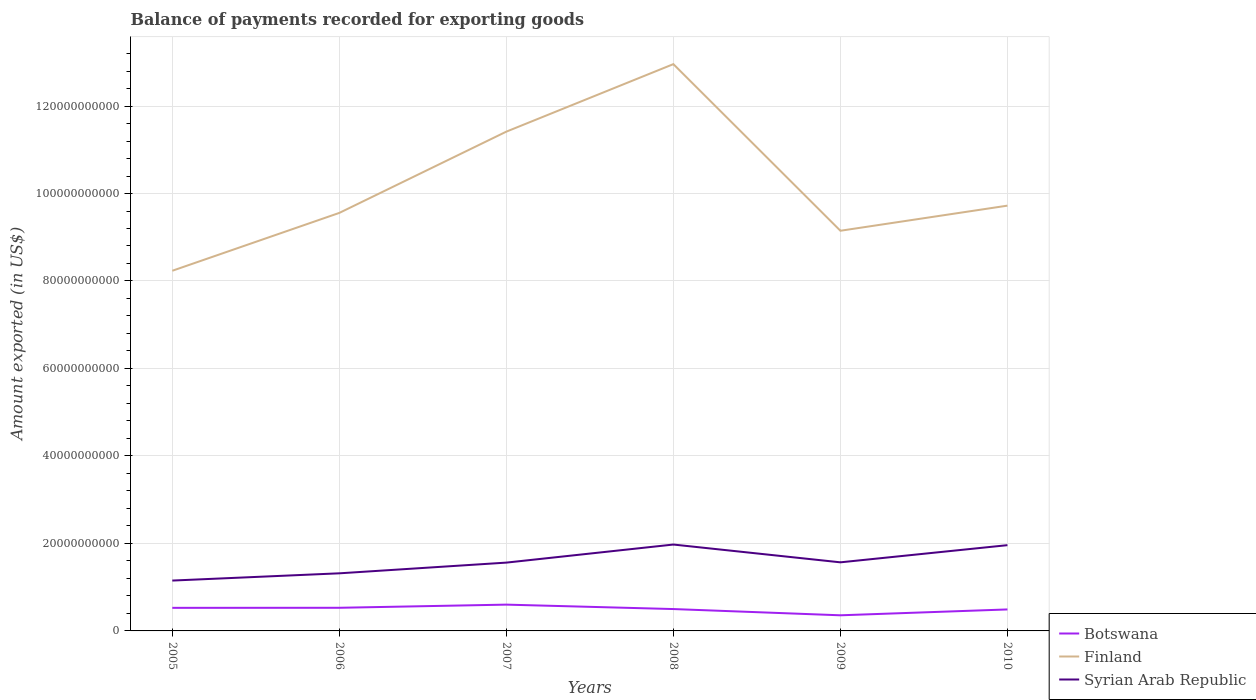Does the line corresponding to Syrian Arab Republic intersect with the line corresponding to Botswana?
Give a very brief answer. No. Across all years, what is the maximum amount exported in Botswana?
Offer a terse response. 3.57e+09. What is the total amount exported in Finland in the graph?
Offer a very short reply. -1.66e+09. What is the difference between the highest and the second highest amount exported in Finland?
Your response must be concise. 4.72e+1. What is the difference between the highest and the lowest amount exported in Syrian Arab Republic?
Ensure brevity in your answer.  2. How many years are there in the graph?
Your answer should be compact. 6. Does the graph contain any zero values?
Keep it short and to the point. No. Where does the legend appear in the graph?
Offer a terse response. Bottom right. How many legend labels are there?
Ensure brevity in your answer.  3. What is the title of the graph?
Your response must be concise. Balance of payments recorded for exporting goods. Does "Maldives" appear as one of the legend labels in the graph?
Provide a short and direct response. No. What is the label or title of the Y-axis?
Provide a succinct answer. Amount exported (in US$). What is the Amount exported (in US$) in Botswana in 2005?
Offer a very short reply. 5.28e+09. What is the Amount exported (in US$) of Finland in 2005?
Your response must be concise. 8.23e+1. What is the Amount exported (in US$) in Syrian Arab Republic in 2005?
Provide a succinct answer. 1.15e+1. What is the Amount exported (in US$) of Botswana in 2006?
Your answer should be very brief. 5.29e+09. What is the Amount exported (in US$) of Finland in 2006?
Offer a very short reply. 9.56e+1. What is the Amount exported (in US$) of Syrian Arab Republic in 2006?
Provide a short and direct response. 1.32e+1. What is the Amount exported (in US$) of Botswana in 2007?
Your answer should be compact. 6.01e+09. What is the Amount exported (in US$) in Finland in 2007?
Make the answer very short. 1.14e+11. What is the Amount exported (in US$) of Syrian Arab Republic in 2007?
Your answer should be compact. 1.56e+1. What is the Amount exported (in US$) in Botswana in 2008?
Ensure brevity in your answer.  5.00e+09. What is the Amount exported (in US$) in Finland in 2008?
Offer a very short reply. 1.30e+11. What is the Amount exported (in US$) of Syrian Arab Republic in 2008?
Keep it short and to the point. 1.97e+1. What is the Amount exported (in US$) in Botswana in 2009?
Provide a succinct answer. 3.57e+09. What is the Amount exported (in US$) in Finland in 2009?
Ensure brevity in your answer.  9.15e+1. What is the Amount exported (in US$) in Syrian Arab Republic in 2009?
Make the answer very short. 1.57e+1. What is the Amount exported (in US$) of Botswana in 2010?
Your response must be concise. 4.91e+09. What is the Amount exported (in US$) in Finland in 2010?
Keep it short and to the point. 9.72e+1. What is the Amount exported (in US$) of Syrian Arab Republic in 2010?
Provide a succinct answer. 1.96e+1. Across all years, what is the maximum Amount exported (in US$) in Botswana?
Provide a short and direct response. 6.01e+09. Across all years, what is the maximum Amount exported (in US$) in Finland?
Your response must be concise. 1.30e+11. Across all years, what is the maximum Amount exported (in US$) of Syrian Arab Republic?
Ensure brevity in your answer.  1.97e+1. Across all years, what is the minimum Amount exported (in US$) in Botswana?
Your answer should be compact. 3.57e+09. Across all years, what is the minimum Amount exported (in US$) in Finland?
Keep it short and to the point. 8.23e+1. Across all years, what is the minimum Amount exported (in US$) of Syrian Arab Republic?
Your answer should be very brief. 1.15e+1. What is the total Amount exported (in US$) of Botswana in the graph?
Your answer should be very brief. 3.01e+1. What is the total Amount exported (in US$) of Finland in the graph?
Your answer should be compact. 6.10e+11. What is the total Amount exported (in US$) of Syrian Arab Republic in the graph?
Your answer should be compact. 9.53e+1. What is the difference between the Amount exported (in US$) in Botswana in 2005 and that in 2006?
Provide a short and direct response. -1.42e+07. What is the difference between the Amount exported (in US$) in Finland in 2005 and that in 2006?
Give a very brief answer. -1.32e+1. What is the difference between the Amount exported (in US$) of Syrian Arab Republic in 2005 and that in 2006?
Keep it short and to the point. -1.66e+09. What is the difference between the Amount exported (in US$) of Botswana in 2005 and that in 2007?
Ensure brevity in your answer.  -7.35e+08. What is the difference between the Amount exported (in US$) of Finland in 2005 and that in 2007?
Provide a short and direct response. -3.18e+1. What is the difference between the Amount exported (in US$) of Syrian Arab Republic in 2005 and that in 2007?
Provide a short and direct response. -4.11e+09. What is the difference between the Amount exported (in US$) in Botswana in 2005 and that in 2008?
Provide a short and direct response. 2.78e+08. What is the difference between the Amount exported (in US$) in Finland in 2005 and that in 2008?
Offer a terse response. -4.72e+1. What is the difference between the Amount exported (in US$) of Syrian Arab Republic in 2005 and that in 2008?
Provide a short and direct response. -8.24e+09. What is the difference between the Amount exported (in US$) in Botswana in 2005 and that in 2009?
Ensure brevity in your answer.  1.70e+09. What is the difference between the Amount exported (in US$) in Finland in 2005 and that in 2009?
Give a very brief answer. -9.15e+09. What is the difference between the Amount exported (in US$) of Syrian Arab Republic in 2005 and that in 2009?
Your response must be concise. -4.17e+09. What is the difference between the Amount exported (in US$) of Botswana in 2005 and that in 2010?
Ensure brevity in your answer.  3.64e+08. What is the difference between the Amount exported (in US$) of Finland in 2005 and that in 2010?
Give a very brief answer. -1.49e+1. What is the difference between the Amount exported (in US$) of Syrian Arab Republic in 2005 and that in 2010?
Your answer should be compact. -8.09e+09. What is the difference between the Amount exported (in US$) of Botswana in 2006 and that in 2007?
Your answer should be compact. -7.20e+08. What is the difference between the Amount exported (in US$) in Finland in 2006 and that in 2007?
Provide a short and direct response. -1.86e+1. What is the difference between the Amount exported (in US$) in Syrian Arab Republic in 2006 and that in 2007?
Give a very brief answer. -2.45e+09. What is the difference between the Amount exported (in US$) in Botswana in 2006 and that in 2008?
Your answer should be compact. 2.92e+08. What is the difference between the Amount exported (in US$) of Finland in 2006 and that in 2008?
Offer a very short reply. -3.40e+1. What is the difference between the Amount exported (in US$) of Syrian Arab Republic in 2006 and that in 2008?
Keep it short and to the point. -6.58e+09. What is the difference between the Amount exported (in US$) of Botswana in 2006 and that in 2009?
Ensure brevity in your answer.  1.72e+09. What is the difference between the Amount exported (in US$) of Finland in 2006 and that in 2009?
Ensure brevity in your answer.  4.08e+09. What is the difference between the Amount exported (in US$) of Syrian Arab Republic in 2006 and that in 2009?
Your answer should be very brief. -2.51e+09. What is the difference between the Amount exported (in US$) of Botswana in 2006 and that in 2010?
Provide a succinct answer. 3.78e+08. What is the difference between the Amount exported (in US$) of Finland in 2006 and that in 2010?
Ensure brevity in your answer.  -1.66e+09. What is the difference between the Amount exported (in US$) in Syrian Arab Republic in 2006 and that in 2010?
Your answer should be compact. -6.44e+09. What is the difference between the Amount exported (in US$) in Botswana in 2007 and that in 2008?
Ensure brevity in your answer.  1.01e+09. What is the difference between the Amount exported (in US$) of Finland in 2007 and that in 2008?
Give a very brief answer. -1.54e+1. What is the difference between the Amount exported (in US$) of Syrian Arab Republic in 2007 and that in 2008?
Provide a short and direct response. -4.13e+09. What is the difference between the Amount exported (in US$) of Botswana in 2007 and that in 2009?
Offer a very short reply. 2.44e+09. What is the difference between the Amount exported (in US$) of Finland in 2007 and that in 2009?
Ensure brevity in your answer.  2.27e+1. What is the difference between the Amount exported (in US$) of Syrian Arab Republic in 2007 and that in 2009?
Your answer should be very brief. -6.49e+07. What is the difference between the Amount exported (in US$) of Botswana in 2007 and that in 2010?
Provide a succinct answer. 1.10e+09. What is the difference between the Amount exported (in US$) of Finland in 2007 and that in 2010?
Make the answer very short. 1.69e+1. What is the difference between the Amount exported (in US$) in Syrian Arab Republic in 2007 and that in 2010?
Give a very brief answer. -3.99e+09. What is the difference between the Amount exported (in US$) in Botswana in 2008 and that in 2009?
Your answer should be very brief. 1.43e+09. What is the difference between the Amount exported (in US$) of Finland in 2008 and that in 2009?
Give a very brief answer. 3.81e+1. What is the difference between the Amount exported (in US$) in Syrian Arab Republic in 2008 and that in 2009?
Your response must be concise. 4.07e+09. What is the difference between the Amount exported (in US$) of Botswana in 2008 and that in 2010?
Provide a succinct answer. 8.60e+07. What is the difference between the Amount exported (in US$) in Finland in 2008 and that in 2010?
Ensure brevity in your answer.  3.24e+1. What is the difference between the Amount exported (in US$) in Syrian Arab Republic in 2008 and that in 2010?
Your answer should be compact. 1.44e+08. What is the difference between the Amount exported (in US$) in Botswana in 2009 and that in 2010?
Offer a terse response. -1.34e+09. What is the difference between the Amount exported (in US$) of Finland in 2009 and that in 2010?
Offer a terse response. -5.74e+09. What is the difference between the Amount exported (in US$) of Syrian Arab Republic in 2009 and that in 2010?
Keep it short and to the point. -3.92e+09. What is the difference between the Amount exported (in US$) of Botswana in 2005 and the Amount exported (in US$) of Finland in 2006?
Offer a terse response. -9.03e+1. What is the difference between the Amount exported (in US$) of Botswana in 2005 and the Amount exported (in US$) of Syrian Arab Republic in 2006?
Your answer should be very brief. -7.89e+09. What is the difference between the Amount exported (in US$) in Finland in 2005 and the Amount exported (in US$) in Syrian Arab Republic in 2006?
Give a very brief answer. 6.92e+1. What is the difference between the Amount exported (in US$) in Botswana in 2005 and the Amount exported (in US$) in Finland in 2007?
Your response must be concise. -1.09e+11. What is the difference between the Amount exported (in US$) of Botswana in 2005 and the Amount exported (in US$) of Syrian Arab Republic in 2007?
Provide a short and direct response. -1.03e+1. What is the difference between the Amount exported (in US$) in Finland in 2005 and the Amount exported (in US$) in Syrian Arab Republic in 2007?
Keep it short and to the point. 6.67e+1. What is the difference between the Amount exported (in US$) in Botswana in 2005 and the Amount exported (in US$) in Finland in 2008?
Keep it short and to the point. -1.24e+11. What is the difference between the Amount exported (in US$) of Botswana in 2005 and the Amount exported (in US$) of Syrian Arab Republic in 2008?
Offer a very short reply. -1.45e+1. What is the difference between the Amount exported (in US$) of Finland in 2005 and the Amount exported (in US$) of Syrian Arab Republic in 2008?
Keep it short and to the point. 6.26e+1. What is the difference between the Amount exported (in US$) of Botswana in 2005 and the Amount exported (in US$) of Finland in 2009?
Your response must be concise. -8.62e+1. What is the difference between the Amount exported (in US$) in Botswana in 2005 and the Amount exported (in US$) in Syrian Arab Republic in 2009?
Your response must be concise. -1.04e+1. What is the difference between the Amount exported (in US$) in Finland in 2005 and the Amount exported (in US$) in Syrian Arab Republic in 2009?
Provide a succinct answer. 6.67e+1. What is the difference between the Amount exported (in US$) in Botswana in 2005 and the Amount exported (in US$) in Finland in 2010?
Ensure brevity in your answer.  -9.19e+1. What is the difference between the Amount exported (in US$) in Botswana in 2005 and the Amount exported (in US$) in Syrian Arab Republic in 2010?
Your response must be concise. -1.43e+1. What is the difference between the Amount exported (in US$) of Finland in 2005 and the Amount exported (in US$) of Syrian Arab Republic in 2010?
Make the answer very short. 6.27e+1. What is the difference between the Amount exported (in US$) in Botswana in 2006 and the Amount exported (in US$) in Finland in 2007?
Keep it short and to the point. -1.09e+11. What is the difference between the Amount exported (in US$) of Botswana in 2006 and the Amount exported (in US$) of Syrian Arab Republic in 2007?
Provide a succinct answer. -1.03e+1. What is the difference between the Amount exported (in US$) of Finland in 2006 and the Amount exported (in US$) of Syrian Arab Republic in 2007?
Provide a succinct answer. 7.99e+1. What is the difference between the Amount exported (in US$) of Botswana in 2006 and the Amount exported (in US$) of Finland in 2008?
Provide a succinct answer. -1.24e+11. What is the difference between the Amount exported (in US$) of Botswana in 2006 and the Amount exported (in US$) of Syrian Arab Republic in 2008?
Offer a terse response. -1.45e+1. What is the difference between the Amount exported (in US$) in Finland in 2006 and the Amount exported (in US$) in Syrian Arab Republic in 2008?
Your answer should be very brief. 7.58e+1. What is the difference between the Amount exported (in US$) of Botswana in 2006 and the Amount exported (in US$) of Finland in 2009?
Offer a terse response. -8.62e+1. What is the difference between the Amount exported (in US$) in Botswana in 2006 and the Amount exported (in US$) in Syrian Arab Republic in 2009?
Provide a short and direct response. -1.04e+1. What is the difference between the Amount exported (in US$) in Finland in 2006 and the Amount exported (in US$) in Syrian Arab Republic in 2009?
Make the answer very short. 7.99e+1. What is the difference between the Amount exported (in US$) in Botswana in 2006 and the Amount exported (in US$) in Finland in 2010?
Provide a succinct answer. -9.19e+1. What is the difference between the Amount exported (in US$) in Botswana in 2006 and the Amount exported (in US$) in Syrian Arab Republic in 2010?
Provide a succinct answer. -1.43e+1. What is the difference between the Amount exported (in US$) in Finland in 2006 and the Amount exported (in US$) in Syrian Arab Republic in 2010?
Keep it short and to the point. 7.60e+1. What is the difference between the Amount exported (in US$) in Botswana in 2007 and the Amount exported (in US$) in Finland in 2008?
Give a very brief answer. -1.24e+11. What is the difference between the Amount exported (in US$) of Botswana in 2007 and the Amount exported (in US$) of Syrian Arab Republic in 2008?
Keep it short and to the point. -1.37e+1. What is the difference between the Amount exported (in US$) of Finland in 2007 and the Amount exported (in US$) of Syrian Arab Republic in 2008?
Your answer should be compact. 9.44e+1. What is the difference between the Amount exported (in US$) of Botswana in 2007 and the Amount exported (in US$) of Finland in 2009?
Offer a very short reply. -8.55e+1. What is the difference between the Amount exported (in US$) in Botswana in 2007 and the Amount exported (in US$) in Syrian Arab Republic in 2009?
Make the answer very short. -9.67e+09. What is the difference between the Amount exported (in US$) of Finland in 2007 and the Amount exported (in US$) of Syrian Arab Republic in 2009?
Offer a very short reply. 9.85e+1. What is the difference between the Amount exported (in US$) in Botswana in 2007 and the Amount exported (in US$) in Finland in 2010?
Provide a short and direct response. -9.12e+1. What is the difference between the Amount exported (in US$) of Botswana in 2007 and the Amount exported (in US$) of Syrian Arab Republic in 2010?
Offer a very short reply. -1.36e+1. What is the difference between the Amount exported (in US$) of Finland in 2007 and the Amount exported (in US$) of Syrian Arab Republic in 2010?
Make the answer very short. 9.45e+1. What is the difference between the Amount exported (in US$) in Botswana in 2008 and the Amount exported (in US$) in Finland in 2009?
Your answer should be very brief. -8.65e+1. What is the difference between the Amount exported (in US$) of Botswana in 2008 and the Amount exported (in US$) of Syrian Arab Republic in 2009?
Your answer should be compact. -1.07e+1. What is the difference between the Amount exported (in US$) in Finland in 2008 and the Amount exported (in US$) in Syrian Arab Republic in 2009?
Your answer should be very brief. 1.14e+11. What is the difference between the Amount exported (in US$) in Botswana in 2008 and the Amount exported (in US$) in Finland in 2010?
Your answer should be very brief. -9.22e+1. What is the difference between the Amount exported (in US$) in Botswana in 2008 and the Amount exported (in US$) in Syrian Arab Republic in 2010?
Your answer should be very brief. -1.46e+1. What is the difference between the Amount exported (in US$) of Finland in 2008 and the Amount exported (in US$) of Syrian Arab Republic in 2010?
Give a very brief answer. 1.10e+11. What is the difference between the Amount exported (in US$) in Botswana in 2009 and the Amount exported (in US$) in Finland in 2010?
Make the answer very short. -9.37e+1. What is the difference between the Amount exported (in US$) of Botswana in 2009 and the Amount exported (in US$) of Syrian Arab Republic in 2010?
Provide a succinct answer. -1.60e+1. What is the difference between the Amount exported (in US$) in Finland in 2009 and the Amount exported (in US$) in Syrian Arab Republic in 2010?
Offer a very short reply. 7.19e+1. What is the average Amount exported (in US$) of Botswana per year?
Keep it short and to the point. 5.01e+09. What is the average Amount exported (in US$) of Finland per year?
Your answer should be very brief. 1.02e+11. What is the average Amount exported (in US$) in Syrian Arab Republic per year?
Provide a succinct answer. 1.59e+1. In the year 2005, what is the difference between the Amount exported (in US$) in Botswana and Amount exported (in US$) in Finland?
Offer a very short reply. -7.71e+1. In the year 2005, what is the difference between the Amount exported (in US$) in Botswana and Amount exported (in US$) in Syrian Arab Republic?
Your response must be concise. -6.23e+09. In the year 2005, what is the difference between the Amount exported (in US$) of Finland and Amount exported (in US$) of Syrian Arab Republic?
Ensure brevity in your answer.  7.08e+1. In the year 2006, what is the difference between the Amount exported (in US$) in Botswana and Amount exported (in US$) in Finland?
Provide a succinct answer. -9.03e+1. In the year 2006, what is the difference between the Amount exported (in US$) in Botswana and Amount exported (in US$) in Syrian Arab Republic?
Give a very brief answer. -7.88e+09. In the year 2006, what is the difference between the Amount exported (in US$) of Finland and Amount exported (in US$) of Syrian Arab Republic?
Your response must be concise. 8.24e+1. In the year 2007, what is the difference between the Amount exported (in US$) in Botswana and Amount exported (in US$) in Finland?
Your answer should be very brief. -1.08e+11. In the year 2007, what is the difference between the Amount exported (in US$) of Botswana and Amount exported (in US$) of Syrian Arab Republic?
Offer a very short reply. -9.61e+09. In the year 2007, what is the difference between the Amount exported (in US$) of Finland and Amount exported (in US$) of Syrian Arab Republic?
Give a very brief answer. 9.85e+1. In the year 2008, what is the difference between the Amount exported (in US$) of Botswana and Amount exported (in US$) of Finland?
Keep it short and to the point. -1.25e+11. In the year 2008, what is the difference between the Amount exported (in US$) of Botswana and Amount exported (in US$) of Syrian Arab Republic?
Your answer should be compact. -1.48e+1. In the year 2008, what is the difference between the Amount exported (in US$) in Finland and Amount exported (in US$) in Syrian Arab Republic?
Ensure brevity in your answer.  1.10e+11. In the year 2009, what is the difference between the Amount exported (in US$) of Botswana and Amount exported (in US$) of Finland?
Ensure brevity in your answer.  -8.79e+1. In the year 2009, what is the difference between the Amount exported (in US$) of Botswana and Amount exported (in US$) of Syrian Arab Republic?
Provide a short and direct response. -1.21e+1. In the year 2009, what is the difference between the Amount exported (in US$) in Finland and Amount exported (in US$) in Syrian Arab Republic?
Keep it short and to the point. 7.58e+1. In the year 2010, what is the difference between the Amount exported (in US$) of Botswana and Amount exported (in US$) of Finland?
Offer a very short reply. -9.23e+1. In the year 2010, what is the difference between the Amount exported (in US$) of Botswana and Amount exported (in US$) of Syrian Arab Republic?
Ensure brevity in your answer.  -1.47e+1. In the year 2010, what is the difference between the Amount exported (in US$) of Finland and Amount exported (in US$) of Syrian Arab Republic?
Offer a very short reply. 7.76e+1. What is the ratio of the Amount exported (in US$) of Finland in 2005 to that in 2006?
Your answer should be very brief. 0.86. What is the ratio of the Amount exported (in US$) in Syrian Arab Republic in 2005 to that in 2006?
Your answer should be very brief. 0.87. What is the ratio of the Amount exported (in US$) of Botswana in 2005 to that in 2007?
Offer a terse response. 0.88. What is the ratio of the Amount exported (in US$) in Finland in 2005 to that in 2007?
Keep it short and to the point. 0.72. What is the ratio of the Amount exported (in US$) in Syrian Arab Republic in 2005 to that in 2007?
Ensure brevity in your answer.  0.74. What is the ratio of the Amount exported (in US$) of Botswana in 2005 to that in 2008?
Provide a short and direct response. 1.06. What is the ratio of the Amount exported (in US$) in Finland in 2005 to that in 2008?
Your response must be concise. 0.64. What is the ratio of the Amount exported (in US$) of Syrian Arab Republic in 2005 to that in 2008?
Keep it short and to the point. 0.58. What is the ratio of the Amount exported (in US$) in Botswana in 2005 to that in 2009?
Your answer should be compact. 1.48. What is the ratio of the Amount exported (in US$) of Syrian Arab Republic in 2005 to that in 2009?
Keep it short and to the point. 0.73. What is the ratio of the Amount exported (in US$) in Botswana in 2005 to that in 2010?
Your answer should be very brief. 1.07. What is the ratio of the Amount exported (in US$) in Finland in 2005 to that in 2010?
Your response must be concise. 0.85. What is the ratio of the Amount exported (in US$) in Syrian Arab Republic in 2005 to that in 2010?
Your answer should be compact. 0.59. What is the ratio of the Amount exported (in US$) of Botswana in 2006 to that in 2007?
Provide a short and direct response. 0.88. What is the ratio of the Amount exported (in US$) of Finland in 2006 to that in 2007?
Offer a very short reply. 0.84. What is the ratio of the Amount exported (in US$) in Syrian Arab Republic in 2006 to that in 2007?
Give a very brief answer. 0.84. What is the ratio of the Amount exported (in US$) of Botswana in 2006 to that in 2008?
Make the answer very short. 1.06. What is the ratio of the Amount exported (in US$) of Finland in 2006 to that in 2008?
Your answer should be very brief. 0.74. What is the ratio of the Amount exported (in US$) in Syrian Arab Republic in 2006 to that in 2008?
Give a very brief answer. 0.67. What is the ratio of the Amount exported (in US$) of Botswana in 2006 to that in 2009?
Make the answer very short. 1.48. What is the ratio of the Amount exported (in US$) in Finland in 2006 to that in 2009?
Make the answer very short. 1.04. What is the ratio of the Amount exported (in US$) of Syrian Arab Republic in 2006 to that in 2009?
Offer a very short reply. 0.84. What is the ratio of the Amount exported (in US$) in Botswana in 2006 to that in 2010?
Offer a terse response. 1.08. What is the ratio of the Amount exported (in US$) of Finland in 2006 to that in 2010?
Offer a terse response. 0.98. What is the ratio of the Amount exported (in US$) in Syrian Arab Republic in 2006 to that in 2010?
Offer a very short reply. 0.67. What is the ratio of the Amount exported (in US$) in Botswana in 2007 to that in 2008?
Offer a very short reply. 1.2. What is the ratio of the Amount exported (in US$) of Finland in 2007 to that in 2008?
Keep it short and to the point. 0.88. What is the ratio of the Amount exported (in US$) in Syrian Arab Republic in 2007 to that in 2008?
Give a very brief answer. 0.79. What is the ratio of the Amount exported (in US$) of Botswana in 2007 to that in 2009?
Keep it short and to the point. 1.68. What is the ratio of the Amount exported (in US$) in Finland in 2007 to that in 2009?
Your response must be concise. 1.25. What is the ratio of the Amount exported (in US$) in Syrian Arab Republic in 2007 to that in 2009?
Ensure brevity in your answer.  1. What is the ratio of the Amount exported (in US$) in Botswana in 2007 to that in 2010?
Your answer should be very brief. 1.22. What is the ratio of the Amount exported (in US$) in Finland in 2007 to that in 2010?
Keep it short and to the point. 1.17. What is the ratio of the Amount exported (in US$) in Syrian Arab Republic in 2007 to that in 2010?
Your answer should be compact. 0.8. What is the ratio of the Amount exported (in US$) in Botswana in 2008 to that in 2009?
Your response must be concise. 1.4. What is the ratio of the Amount exported (in US$) of Finland in 2008 to that in 2009?
Provide a short and direct response. 1.42. What is the ratio of the Amount exported (in US$) of Syrian Arab Republic in 2008 to that in 2009?
Provide a short and direct response. 1.26. What is the ratio of the Amount exported (in US$) in Botswana in 2008 to that in 2010?
Provide a short and direct response. 1.02. What is the ratio of the Amount exported (in US$) of Finland in 2008 to that in 2010?
Give a very brief answer. 1.33. What is the ratio of the Amount exported (in US$) of Syrian Arab Republic in 2008 to that in 2010?
Your answer should be compact. 1.01. What is the ratio of the Amount exported (in US$) of Botswana in 2009 to that in 2010?
Your answer should be compact. 0.73. What is the ratio of the Amount exported (in US$) of Finland in 2009 to that in 2010?
Offer a very short reply. 0.94. What is the ratio of the Amount exported (in US$) in Syrian Arab Republic in 2009 to that in 2010?
Provide a short and direct response. 0.8. What is the difference between the highest and the second highest Amount exported (in US$) in Botswana?
Keep it short and to the point. 7.20e+08. What is the difference between the highest and the second highest Amount exported (in US$) of Finland?
Ensure brevity in your answer.  1.54e+1. What is the difference between the highest and the second highest Amount exported (in US$) of Syrian Arab Republic?
Offer a very short reply. 1.44e+08. What is the difference between the highest and the lowest Amount exported (in US$) in Botswana?
Give a very brief answer. 2.44e+09. What is the difference between the highest and the lowest Amount exported (in US$) in Finland?
Offer a very short reply. 4.72e+1. What is the difference between the highest and the lowest Amount exported (in US$) of Syrian Arab Republic?
Your answer should be very brief. 8.24e+09. 